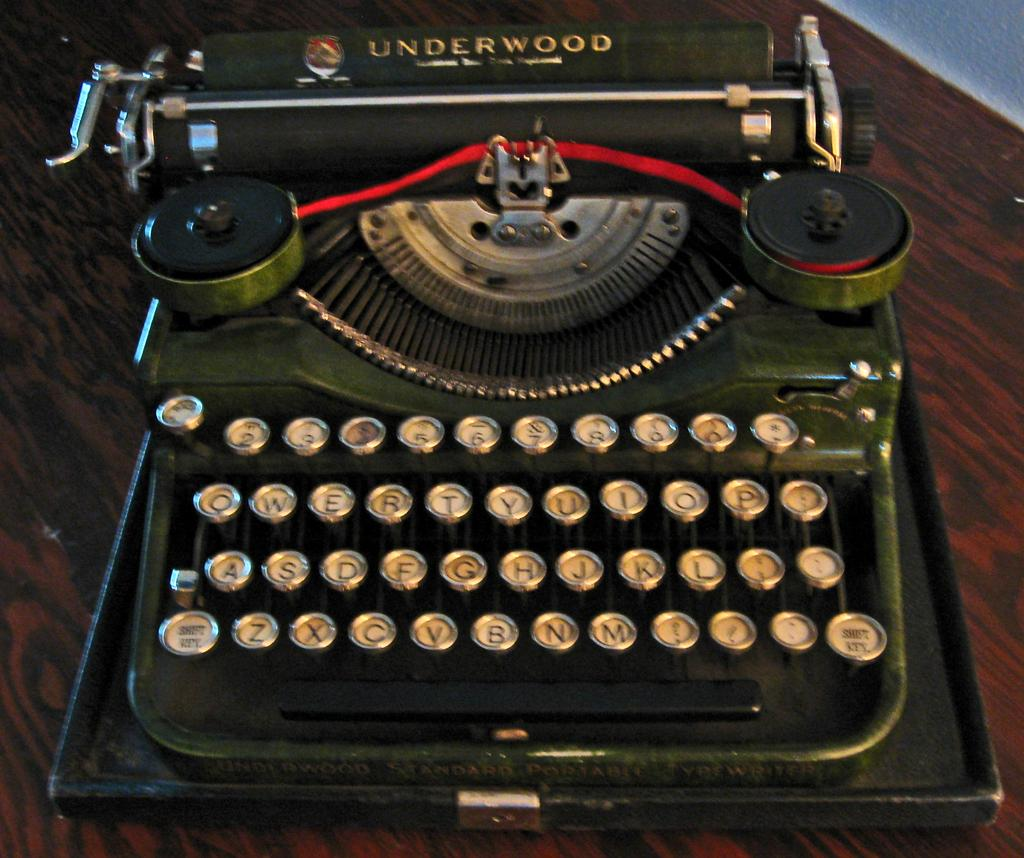<image>
Summarize the visual content of the image. An antique Underwood typewriter sits on a dark wood table. 